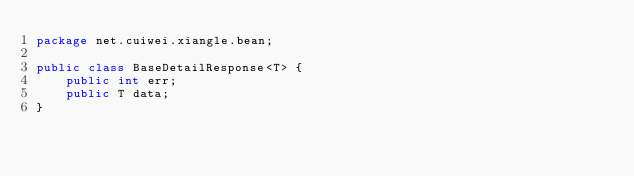Convert code to text. <code><loc_0><loc_0><loc_500><loc_500><_Java_>package net.cuiwei.xiangle.bean;

public class BaseDetailResponse<T> {
    public int err;
    public T data;
}
</code> 